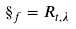Convert formula to latex. <formula><loc_0><loc_0><loc_500><loc_500>\S _ { f } = R _ { t , \lambda }</formula> 